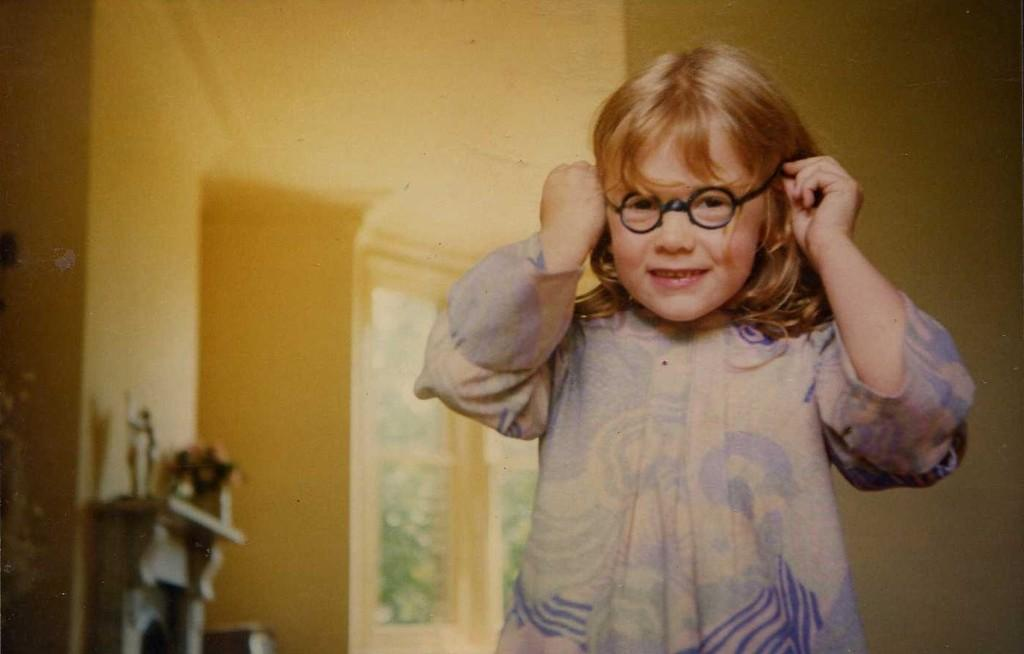What is the main subject of the image? There is a person in the image. What is the person holding in the image? The person is holding spectacles. What can be seen in the background of the image? There is a wall and objects visible in the background of the image. Can you tell me how many geese are resting on the wall in the image? There are no geese present in the image, so it is not possible to determine how many might be resting on the wall. 